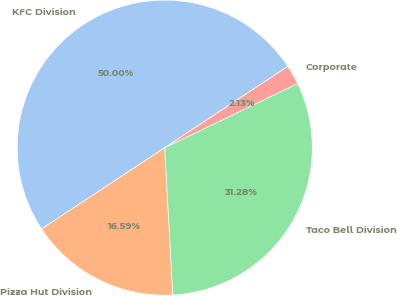<chart> <loc_0><loc_0><loc_500><loc_500><pie_chart><fcel>KFC Division<fcel>Pizza Hut Division<fcel>Taco Bell Division<fcel>Corporate<nl><fcel>50.0%<fcel>16.59%<fcel>31.28%<fcel>2.13%<nl></chart> 